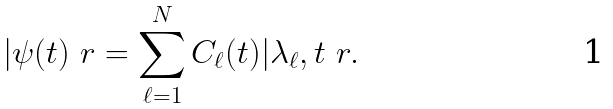Convert formula to latex. <formula><loc_0><loc_0><loc_500><loc_500>| \psi ( t ) \ r = \sum _ { \ell = 1 } ^ { N } C _ { \ell } ( t ) | \lambda _ { \ell } , t \ r .</formula> 